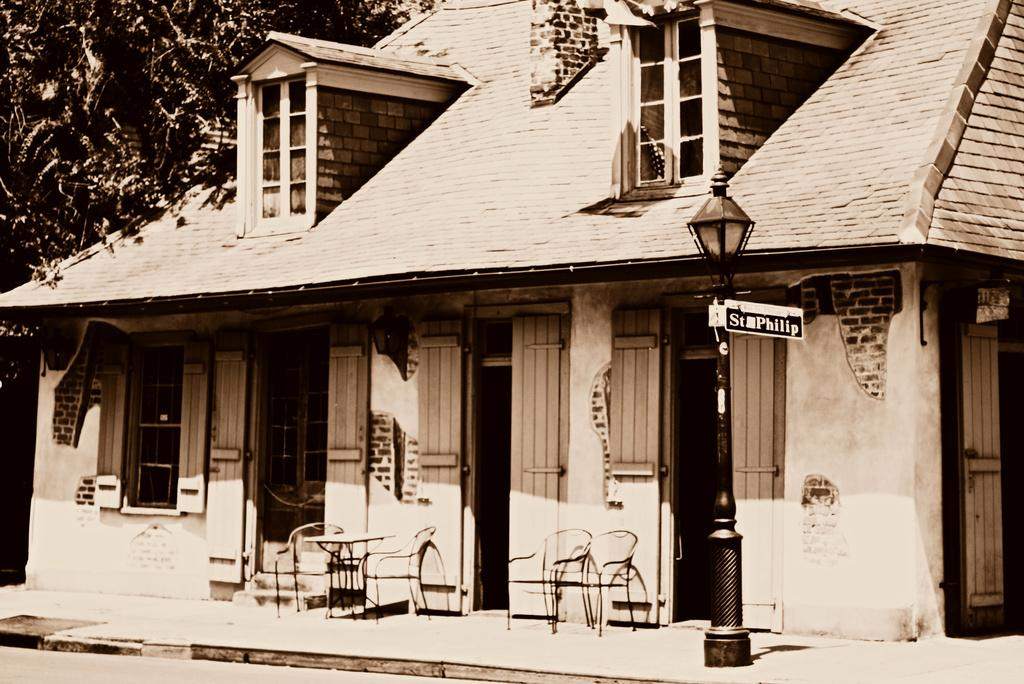What type of structure is visible in the image? There is a house in the image. What objects are placed in front of the house? There are chairs in front of the house. Where is the tree located in the image? The tree is in the left corner of the image. What type of stamp can be seen on the tree in the image? There is no stamp present on the tree in the image. 